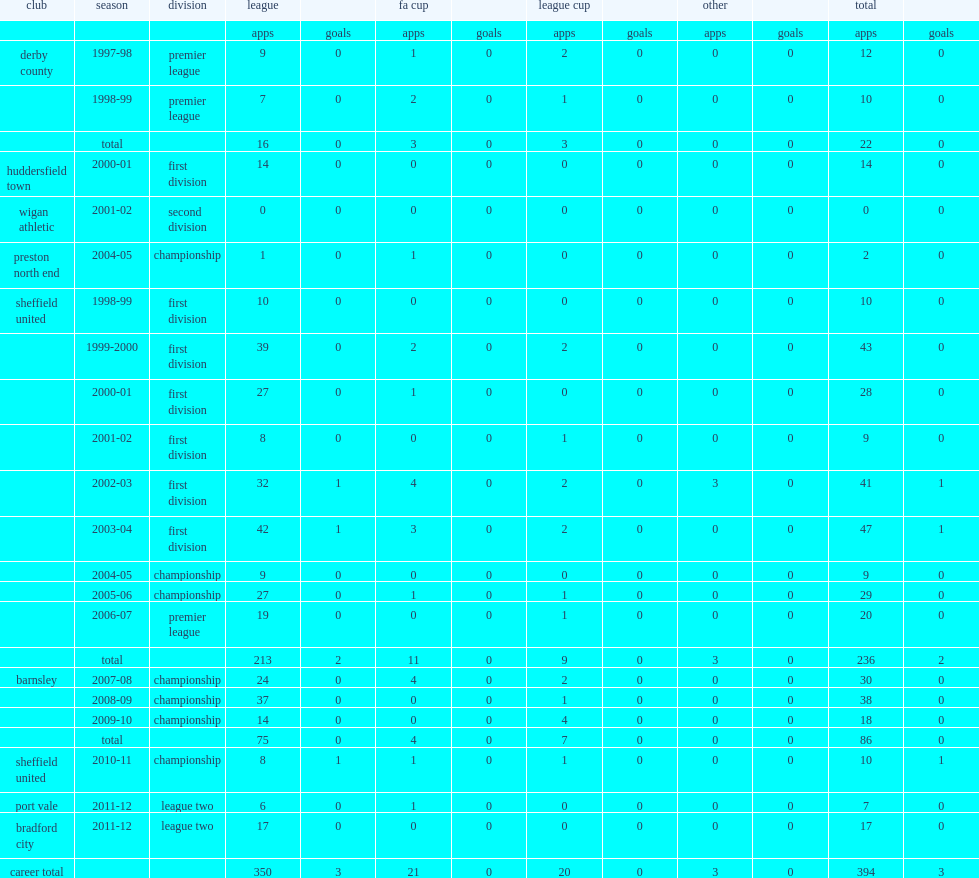What was the number of league and cup appearances made by rob kozluk for the club sheffield united. 236.0. 